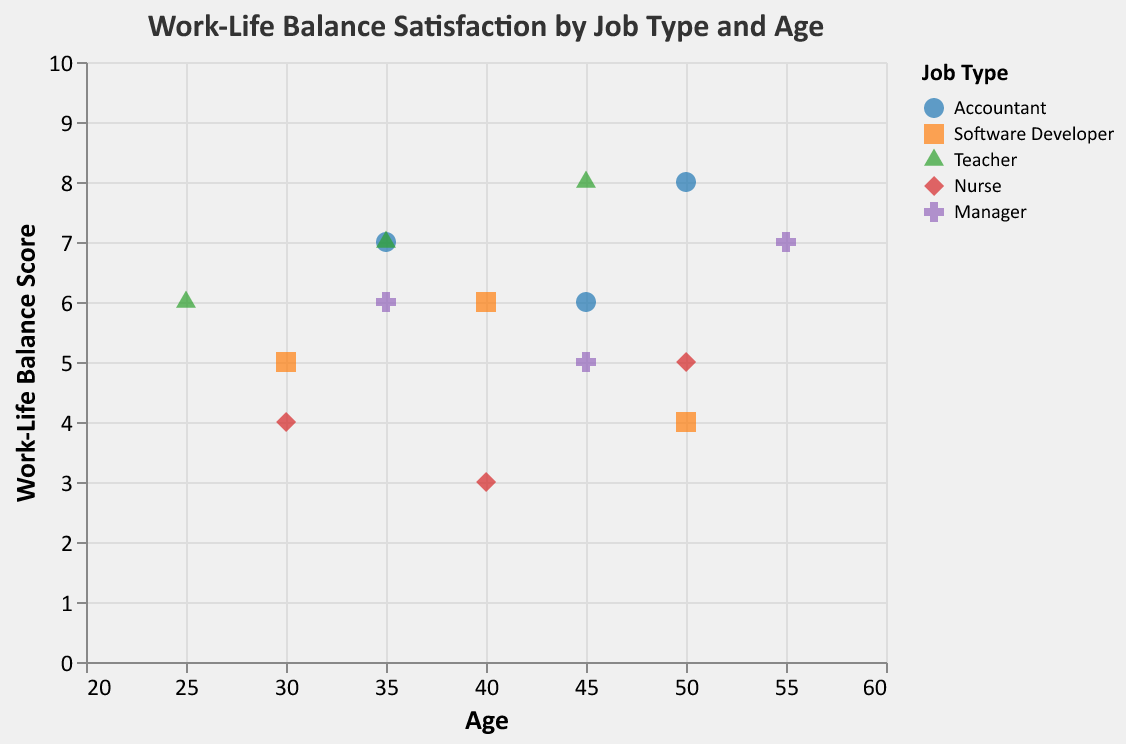What is the Work-Life Balance Satisfaction score for the 45-year-old accountant? From the legend, we know "Accountant" is represented by blue circles. By locating the blue circle at Age 45 along the x-axis, we find it is at Work-Life Balance Score 6.
Answer: 6 Which job type has the highest Work-Life Balance Satisfaction score? By observing all data points and their corresponding colors and shapes, the highest score is 8, visible at ages 45 for "Teacher" (green triangle) and 50 for "Accountant" (blue circle).
Answer: Teacher and Accountant What is the average Work-Life Balance Satisfaction score for software developers? The scores for software developers (orange squares) are 5, 6, and 4. Summing these scores, we get 5 + 6 + 4 = 15. Dividing by the number of scores (3), the average is 15 / 3 = 5.
Answer: 5 At what age does the nurse have the lowest Work-Life Balance Satisfaction score? Nurses are represented by red diamonds. The red diamond with the lowest score appears at age 40, and the score is 3.
Answer: 40 Compare the Work-Life Balance Satisfaction score of the 50-year-old nurse and the 50-year-old accountant. By examining the red diamond at age 50 for nurses and the blue circle at age 50 for accountants, their scores are 5 and 8, respectively. Thus, the 50-year-old accountant has a higher score.
Answer: Accountant's score is higher How many total data points are there in the plot? There are 5 different job types, and each has three different age data points, making it 5 * 3 = 15 data points total.
Answer: 15 What job types have a Work-Life Balance score of 6 across any age group? Looking at the y-axis at score 6, the job types are "Accountant" (age 45), "Software Developer" (age 40), "Teacher" (age 25), and "Manager" (age 35).
Answer: Accountant, Software Developer, Teacher, and Manager Is there any age where the Work-Life Balance Satisfaction score is 7, regardless of job type? By looking at the y-axis at score 7, there are two points: one at age 35 for "Accountant" (blue circle) and one at age 35 for "Teacher" (green triangle). So, age 35 has a score of 7.
Answer: Yes, age 35 